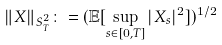Convert formula to latex. <formula><loc_0><loc_0><loc_500><loc_500>\| X \| _ { S _ { T } ^ { 2 } } \colon = ( \mathbb { E } [ \sup _ { s \in [ 0 , T ] } | X _ { s } | ^ { 2 } ] ) ^ { 1 / 2 }</formula> 